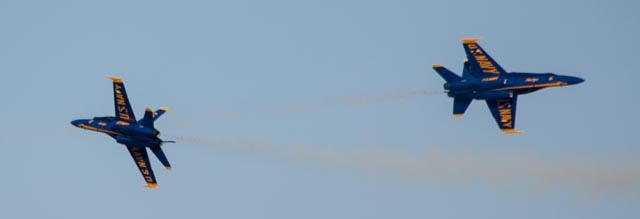Describe the objects in this image and their specific colors. I can see airplane in darkgray, navy, black, gray, and brown tones and airplane in darkgray, black, navy, and gray tones in this image. 